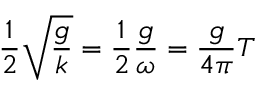<formula> <loc_0><loc_0><loc_500><loc_500>{ \frac { 1 } { 2 } } { \sqrt { \frac { g } { k } } } = { \frac { 1 } { 2 } } { \frac { g } { \omega } } = { \frac { g } { 4 \pi } } T</formula> 